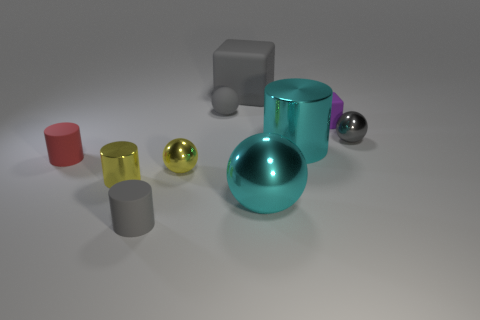How many things are either tiny cylinders that are behind the tiny yellow metallic cylinder or gray things that are to the right of the small rubber cube?
Give a very brief answer. 2. There is a cube that is right of the large gray object; how many shiny balls are right of it?
Your answer should be very brief. 1. Is the shape of the gray thing that is in front of the small gray metallic object the same as the large object that is behind the gray metal thing?
Provide a short and direct response. No. There is a big rubber thing that is the same color as the small matte ball; what is its shape?
Offer a terse response. Cube. Are there any large objects that have the same material as the tiny yellow cylinder?
Your response must be concise. Yes. What number of metal objects are either small red objects or large cylinders?
Your answer should be compact. 1. There is a rubber object to the right of the shiny cylinder that is right of the small gray matte cylinder; what is its shape?
Offer a very short reply. Cube. Are there fewer large cyan shiny cylinders that are on the right side of the tiny block than big cyan metal things?
Give a very brief answer. Yes. What is the shape of the tiny red rubber thing?
Your response must be concise. Cylinder. What size is the cyan object that is behind the big cyan ball?
Your response must be concise. Large. 